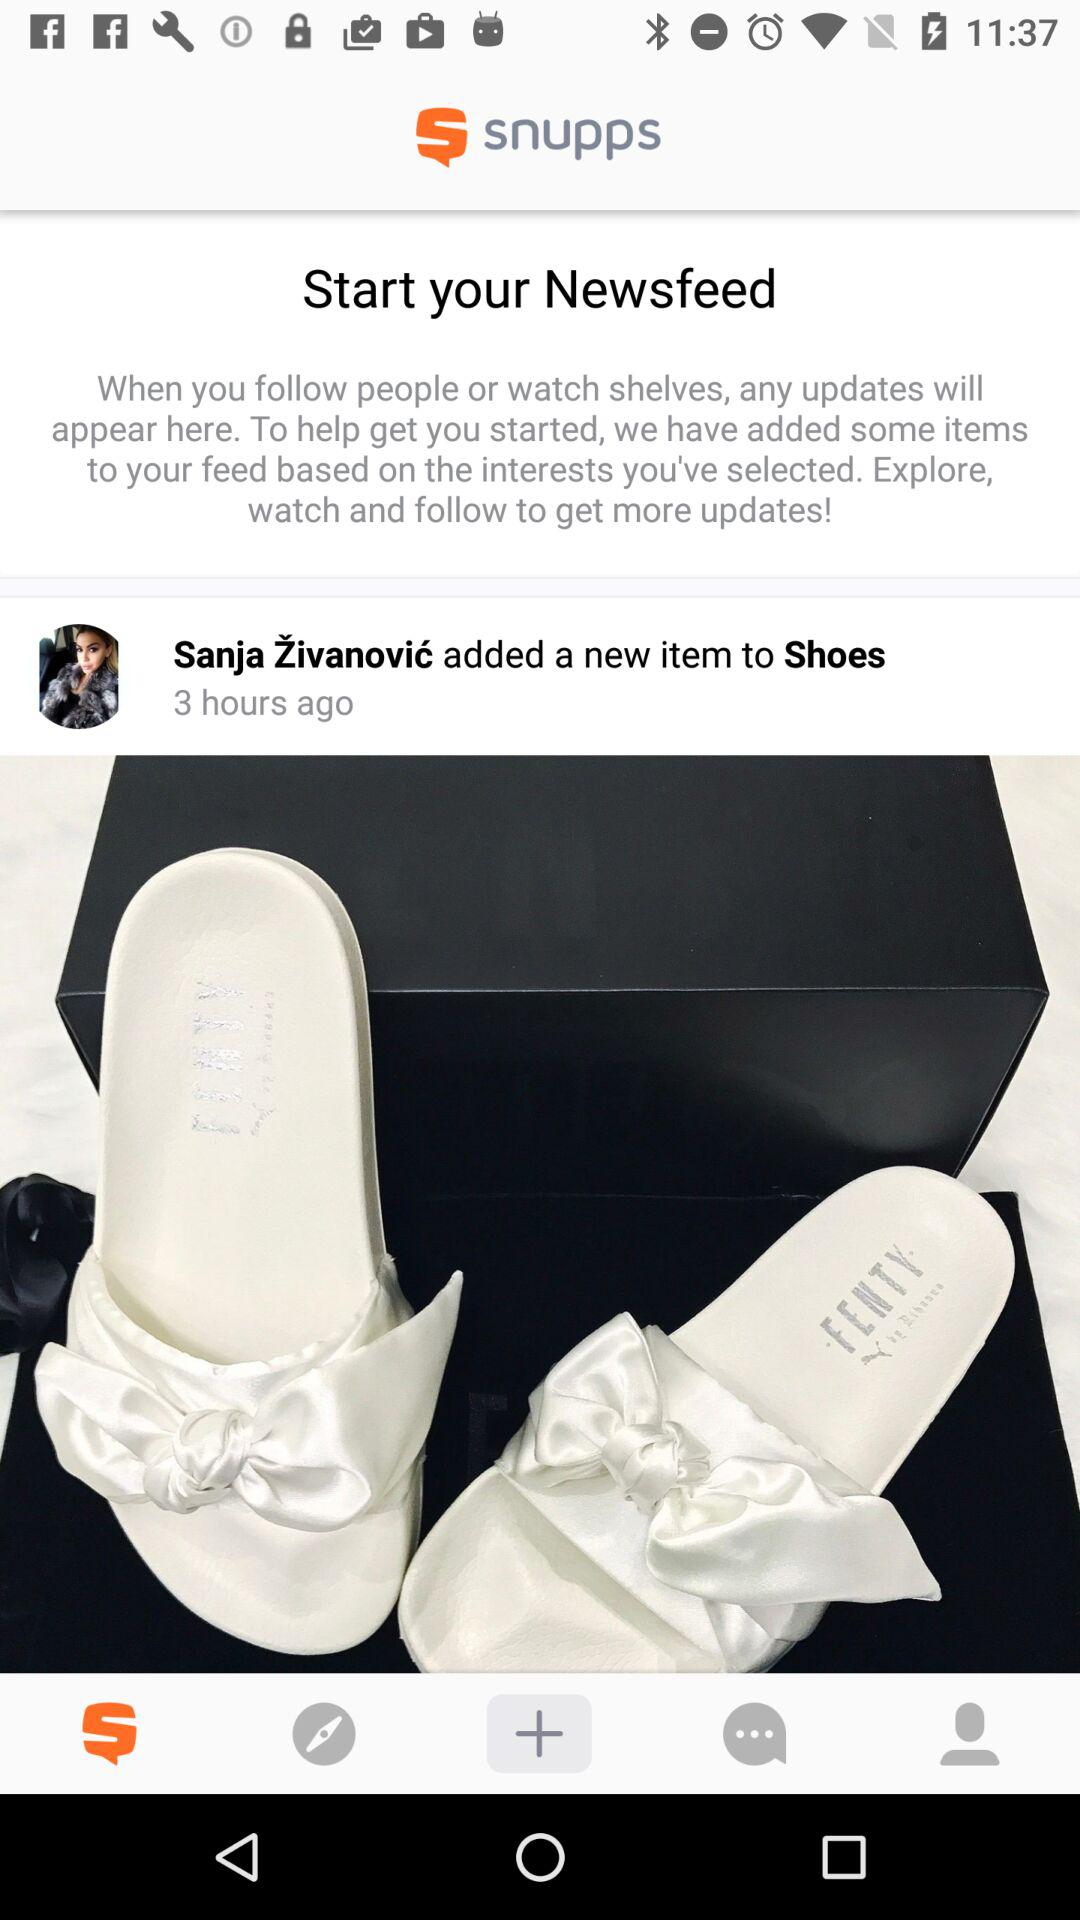What is the application name? The application name is "snupps". 